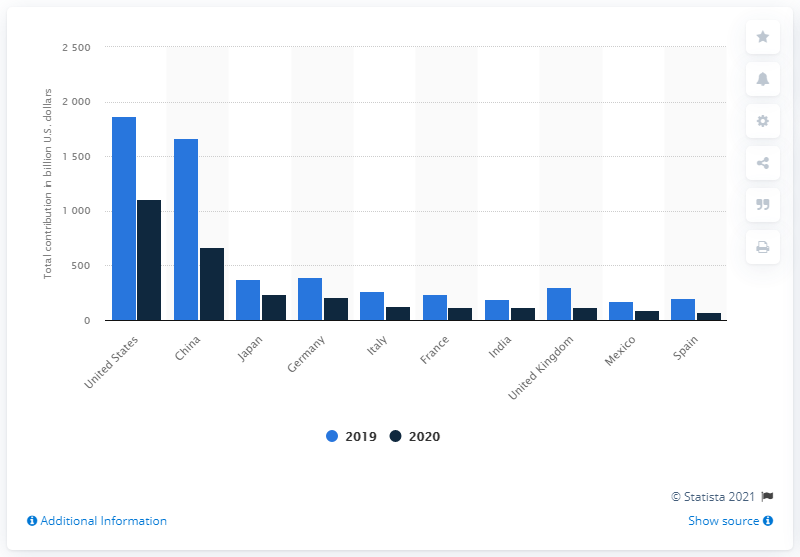Highlight a few significant elements in this photo. In 2020, China's contribution to GDP was 667.2%. In 2020, the travel and tourism industries made a significant contribution to the country's Gross Domestic Product, amounting to 1103.7…. 